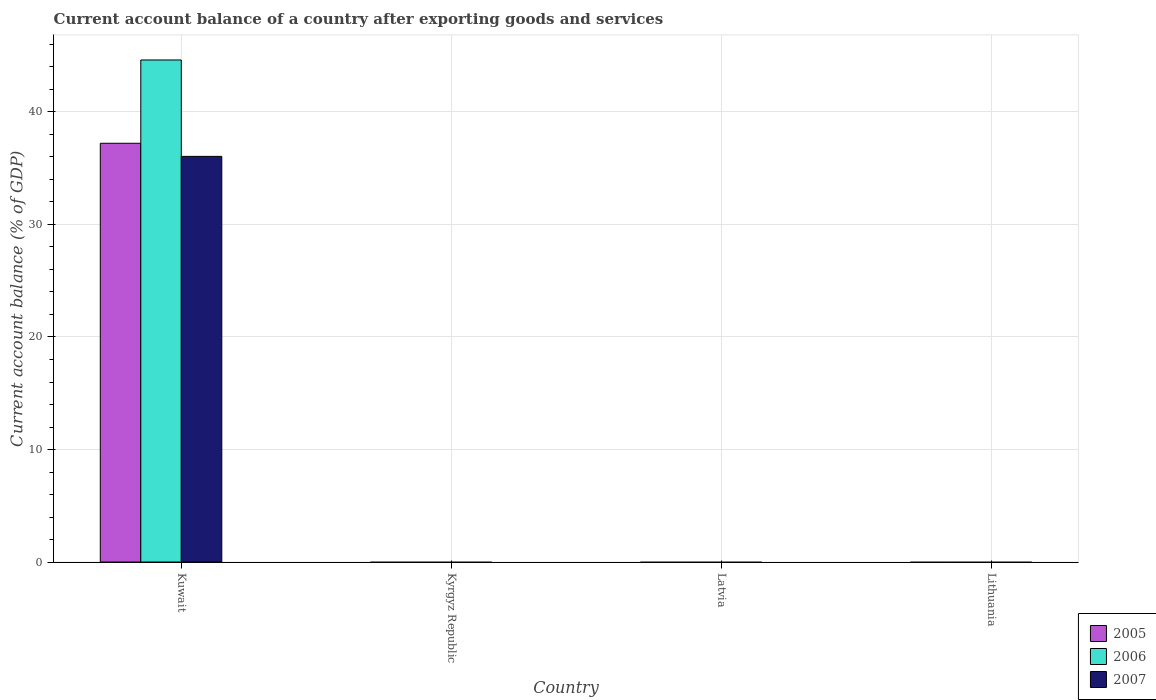How many different coloured bars are there?
Your answer should be compact. 3. Are the number of bars per tick equal to the number of legend labels?
Offer a terse response. No. Are the number of bars on each tick of the X-axis equal?
Ensure brevity in your answer.  No. How many bars are there on the 3rd tick from the left?
Your answer should be compact. 0. What is the label of the 2nd group of bars from the left?
Keep it short and to the point. Kyrgyz Republic. Across all countries, what is the maximum account balance in 2006?
Give a very brief answer. 44.62. Across all countries, what is the minimum account balance in 2007?
Ensure brevity in your answer.  0. In which country was the account balance in 2006 maximum?
Make the answer very short. Kuwait. What is the total account balance in 2005 in the graph?
Ensure brevity in your answer.  37.22. What is the difference between the account balance in 2007 in Kuwait and the account balance in 2005 in Latvia?
Your answer should be compact. 36.05. What is the average account balance in 2005 per country?
Offer a terse response. 9.3. What is the difference between the account balance of/in 2007 and account balance of/in 2006 in Kuwait?
Keep it short and to the point. -8.57. In how many countries, is the account balance in 2006 greater than 32 %?
Your answer should be compact. 1. What is the difference between the highest and the lowest account balance in 2005?
Your response must be concise. 37.22. How many bars are there?
Your answer should be compact. 3. Are all the bars in the graph horizontal?
Your response must be concise. No. How many countries are there in the graph?
Your answer should be compact. 4. What is the difference between two consecutive major ticks on the Y-axis?
Offer a very short reply. 10. Are the values on the major ticks of Y-axis written in scientific E-notation?
Your answer should be very brief. No. Does the graph contain grids?
Your answer should be very brief. Yes. How many legend labels are there?
Provide a succinct answer. 3. What is the title of the graph?
Keep it short and to the point. Current account balance of a country after exporting goods and services. What is the label or title of the Y-axis?
Your answer should be compact. Current account balance (% of GDP). What is the Current account balance (% of GDP) of 2005 in Kuwait?
Make the answer very short. 37.22. What is the Current account balance (% of GDP) in 2006 in Kuwait?
Provide a short and direct response. 44.62. What is the Current account balance (% of GDP) in 2007 in Kuwait?
Your answer should be compact. 36.05. What is the Current account balance (% of GDP) of 2006 in Kyrgyz Republic?
Your response must be concise. 0. What is the Current account balance (% of GDP) in 2007 in Kyrgyz Republic?
Offer a very short reply. 0. What is the Current account balance (% of GDP) in 2006 in Latvia?
Offer a very short reply. 0. What is the Current account balance (% of GDP) of 2005 in Lithuania?
Your answer should be compact. 0. What is the Current account balance (% of GDP) of 2006 in Lithuania?
Offer a very short reply. 0. Across all countries, what is the maximum Current account balance (% of GDP) in 2005?
Keep it short and to the point. 37.22. Across all countries, what is the maximum Current account balance (% of GDP) in 2006?
Keep it short and to the point. 44.62. Across all countries, what is the maximum Current account balance (% of GDP) of 2007?
Give a very brief answer. 36.05. Across all countries, what is the minimum Current account balance (% of GDP) in 2006?
Offer a terse response. 0. Across all countries, what is the minimum Current account balance (% of GDP) of 2007?
Offer a terse response. 0. What is the total Current account balance (% of GDP) in 2005 in the graph?
Give a very brief answer. 37.22. What is the total Current account balance (% of GDP) in 2006 in the graph?
Your response must be concise. 44.62. What is the total Current account balance (% of GDP) of 2007 in the graph?
Give a very brief answer. 36.05. What is the average Current account balance (% of GDP) of 2005 per country?
Offer a very short reply. 9.3. What is the average Current account balance (% of GDP) of 2006 per country?
Give a very brief answer. 11.15. What is the average Current account balance (% of GDP) of 2007 per country?
Offer a very short reply. 9.01. What is the difference between the Current account balance (% of GDP) of 2005 and Current account balance (% of GDP) of 2006 in Kuwait?
Provide a succinct answer. -7.4. What is the difference between the Current account balance (% of GDP) of 2005 and Current account balance (% of GDP) of 2007 in Kuwait?
Ensure brevity in your answer.  1.17. What is the difference between the Current account balance (% of GDP) in 2006 and Current account balance (% of GDP) in 2007 in Kuwait?
Make the answer very short. 8.57. What is the difference between the highest and the lowest Current account balance (% of GDP) of 2005?
Your answer should be compact. 37.22. What is the difference between the highest and the lowest Current account balance (% of GDP) of 2006?
Offer a very short reply. 44.62. What is the difference between the highest and the lowest Current account balance (% of GDP) in 2007?
Ensure brevity in your answer.  36.05. 